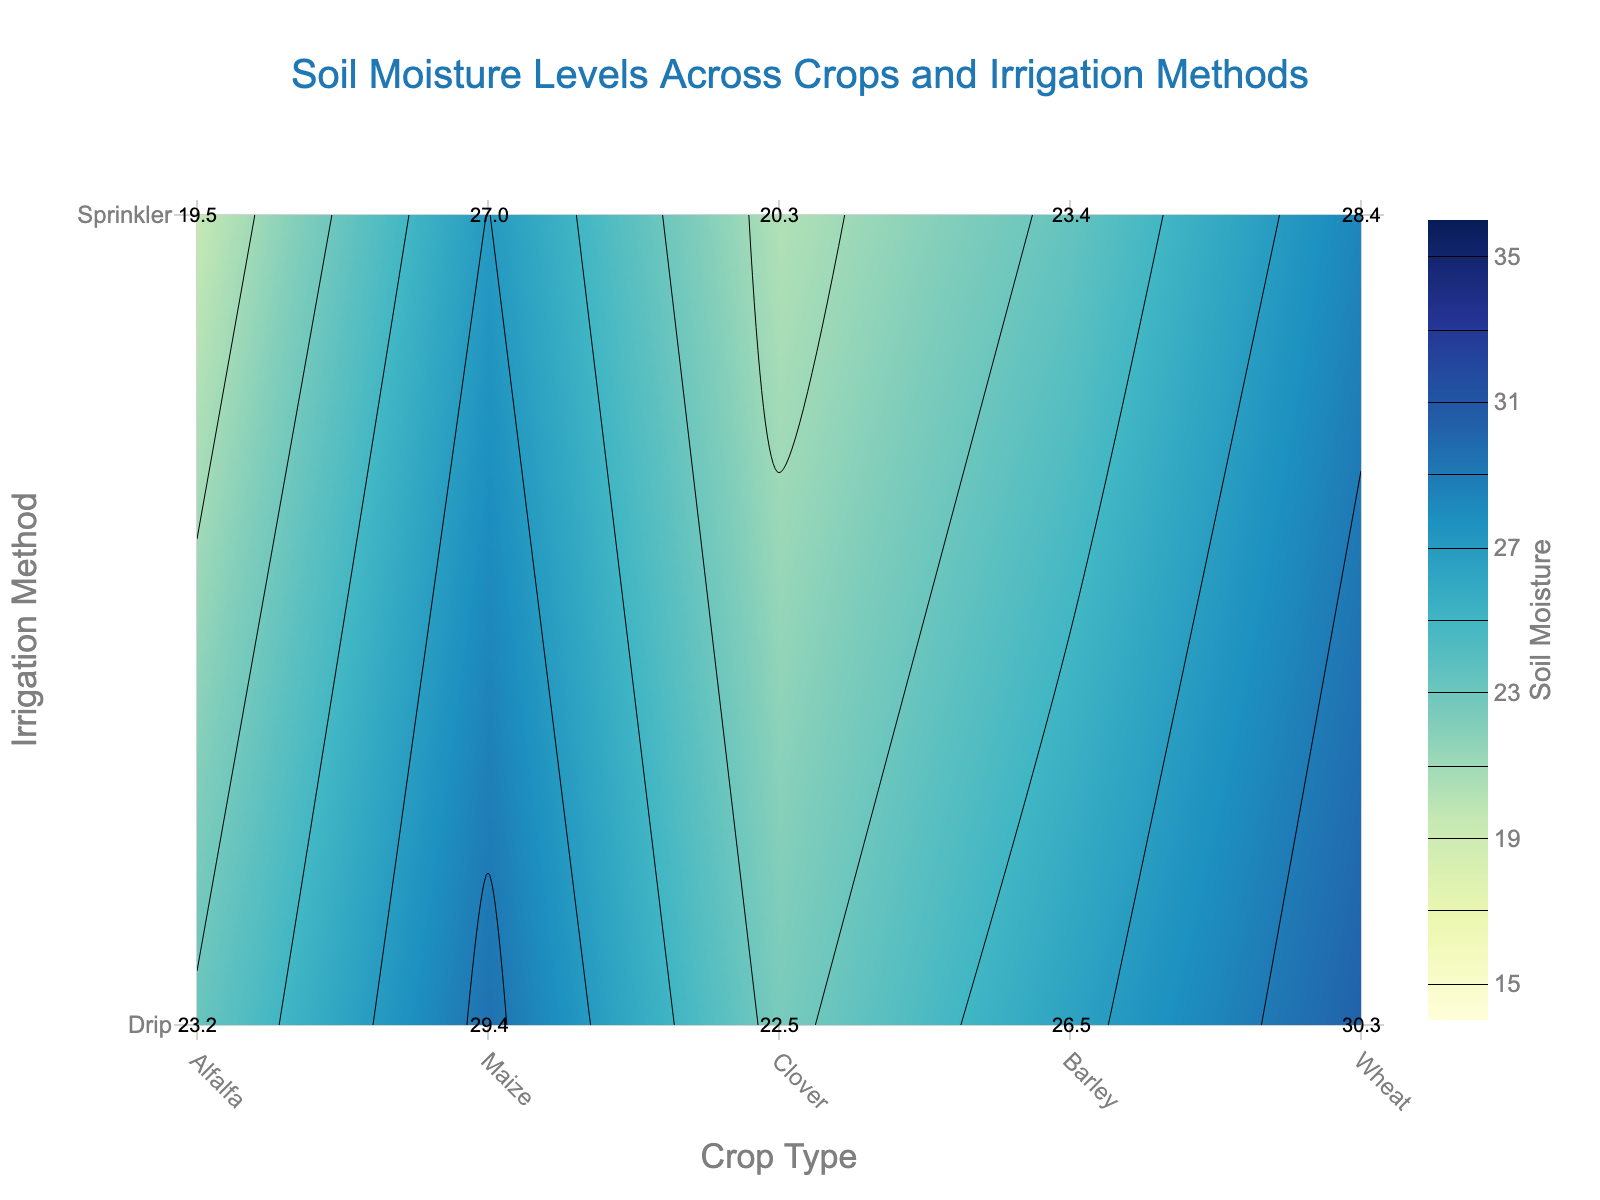What is the title of the figure? The title is prominently displayed at the top of the figure in a larger font size. It reads "Soil Moisture Levels Across Crops and Irrigation Methods."
Answer: Soil Moisture Levels Across Crops and Irrigation Methods Which crop shows the highest soil moisture level when using drip irrigation? Look at the contour plot and identify the highest soil moisture value among crops with drip irrigation. The top values are labeled on the plot.
Answer: Wheat How does the soil moisture level of Alfalfa compare under drip and sprinkler irrigation? Check the soil moisture values for Alfalfa under both drip and sprinkler categories in the plot. Compare these values to see under which method Alfalfa has higher soil moisture.
Answer: Higher under drip irrigation Which irrigation method generally provides higher soil moisture levels for the crops? Compare the general trend and the average moisture levels of the two irrigation methods by looking at multiple crops in the contour plot.
Answer: Drip irrigation What is the range of soil moisture levels shown in the figure? Observe the color scale on the side of the plot, which indicates the minimum and maximum values of soil moisture levels represented in the figure.
Answer: 15 to 35 For Maize, what is the difference in soil moisture levels between the Northern and Southern Plots using sprinkler irrigation? Identify the soil moisture values for Maize in both Northern and Southern Plots with sprinkler irrigation, then subtract the smaller value from the larger one to find the difference.
Answer: 1.7 Which crop has the lowest soil moisture level under any irrigation method? Scan through the figure to find the minimum soil moisture value across all the crops and irrigation methods.
Answer: Alfalfa with Sprinkler Considering only the Southern Plot, which crop has the highest soil moisture level? Focus on the contour plot information for the Southern Plot and compare the soil moisture levels to identify the highest moisture level for a crop.
Answer: Wheat Which cropping method shows more variability in soil moisture levels: drip or sprinkler? Examine the soil moisture levels under both irrigation methods and look for larger fluctuations in values to determine which has more variability.
Answer: Sprinkler How does the soil moisture level of Clover compare under drip irrigation in the Northern Plot versus the Southern Plot? Identify the soil moisture values of Clover under drip irrigation in both Northern and Southern Plots from the figure and make a comparison.
Answer: Higher in Southern Plot 